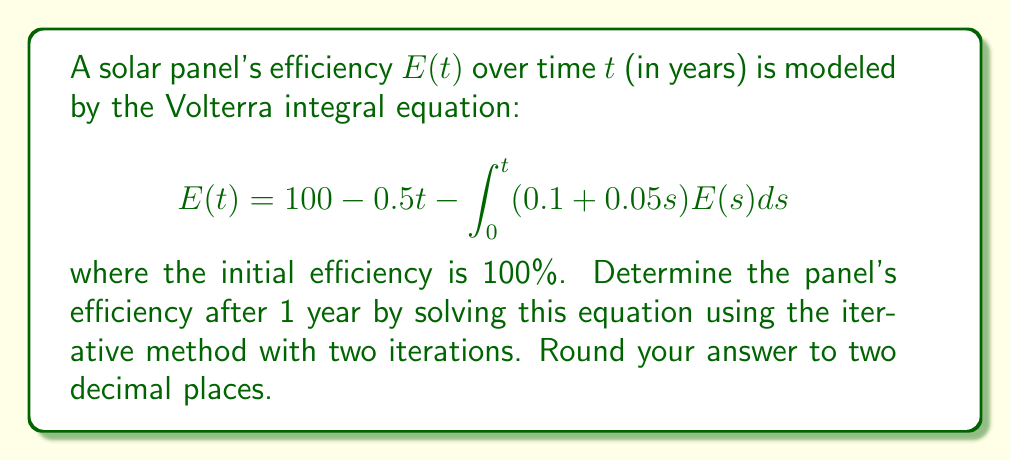Teach me how to tackle this problem. To solve this Volterra integral equation using the iterative method:

1) Start with the initial approximation $E_0(t) = 100 - 0.5t$

2) Use this to compute the first iteration:

   $$\begin{align}
   E_1(t) &= 100 - 0.5t - \int_0^t (0.1 + 0.05s)(100 - 0.5s)ds \\
   &= 100 - 0.5t - \int_0^t (10 - 0.5s + 5s - 0.025s^2)ds \\
   &= 100 - 0.5t - [10s - 0.25s^2 + 2.5s^2 - \frac{0.025}{3}s^3]_0^t \\
   &= 100 - 0.5t - (10t - 0.25t^2 + 2.5t^2 - \frac{0.025}{3}t^3) \\
   &= 100 - 10.5t + 0.25t^2 - 2.5t^2 + \frac{0.025}{3}t^3 \\
   &= 100 - 10.5t - 2.25t^2 + \frac{0.025}{3}t^3
   \end{align}$$

3) Use $E_1(t)$ to compute the second iteration:

   $$\begin{align}
   E_2(t) &= 100 - 0.5t - \int_0^t (0.1 + 0.05s)(100 - 10.5s - 2.25s^2 + \frac{0.025}{3}s^3)ds \\
   &= 100 - 0.5t - \int_0^t (10 - 1.05s - 0.225s^2 + \frac{0.0025}{3}s^3 + 5s - 0.525s^2 - 0.1125s^3 + \frac{0.00125}{3}s^4)ds \\
   &= 100 - 0.5t - [10t - \frac{1.05}{2}t^2 - \frac{0.225}{3}t^3 + \frac{0.0025}{12}t^4 + \frac{5}{2}t^2 - \frac{0.525}{4}t^3 - \frac{0.1125}{4}t^4 + \frac{0.00125}{15}t^5]_0^t \\
   &= 100 - 10.5t + (\frac{1.05}{2} - \frac{5}{2})t^2 + (\frac{0.225}{3} + \frac{0.525}{4})t^3 + (\frac{0.1125}{4} - \frac{0.0025}{12})t^4 - \frac{0.00125}{15}t^5 \\
   &\approx 100 - 10.5t - 0.725t^2 + 0.20625t^3 + 0.028125t^4 - 0.0000833t^5
   \end{align}$$

4) Evaluate $E_2(t)$ at $t = 1$:

   $$\begin{align}
   E_2(1) &\approx 100 - 10.5(1) - 0.725(1)^2 + 0.20625(1)^3 + 0.028125(1)^4 - 0.0000833(1)^5 \\
   &\approx 100 - 10.5 - 0.725 + 0.20625 + 0.028125 - 0.0000833 \\
   &\approx 89.01 \text{ (rounded to two decimal places)}
   \end{align}$$
Answer: 89.01% 